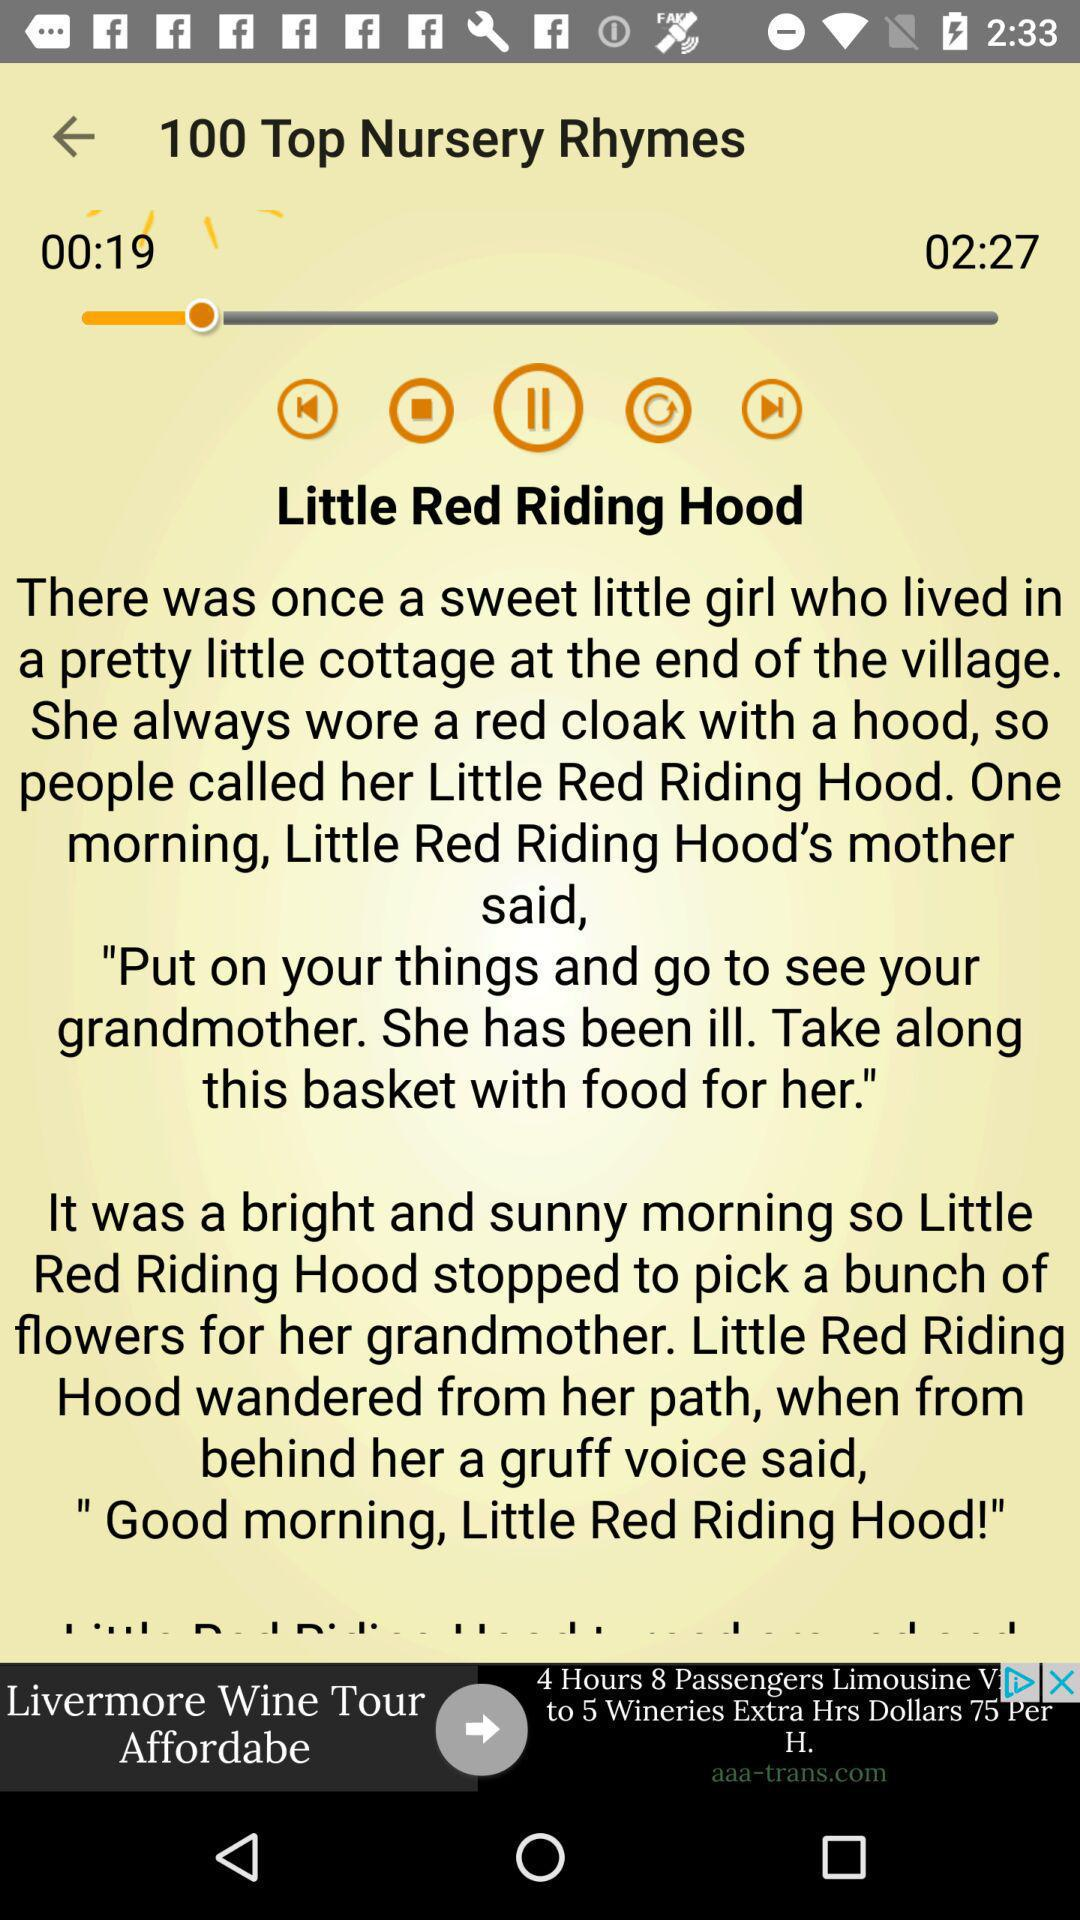What is the title of the rhyme? The title of the rhyme is "Little Red Riding Hood". 